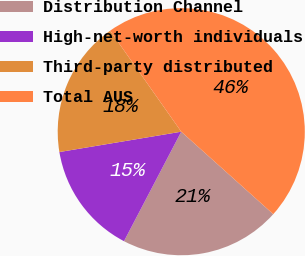Convert chart. <chart><loc_0><loc_0><loc_500><loc_500><pie_chart><fcel>Distribution Channel<fcel>High-net-worth individuals<fcel>Third-party distributed<fcel>Total AUS<nl><fcel>21.04%<fcel>14.7%<fcel>17.87%<fcel>46.4%<nl></chart> 